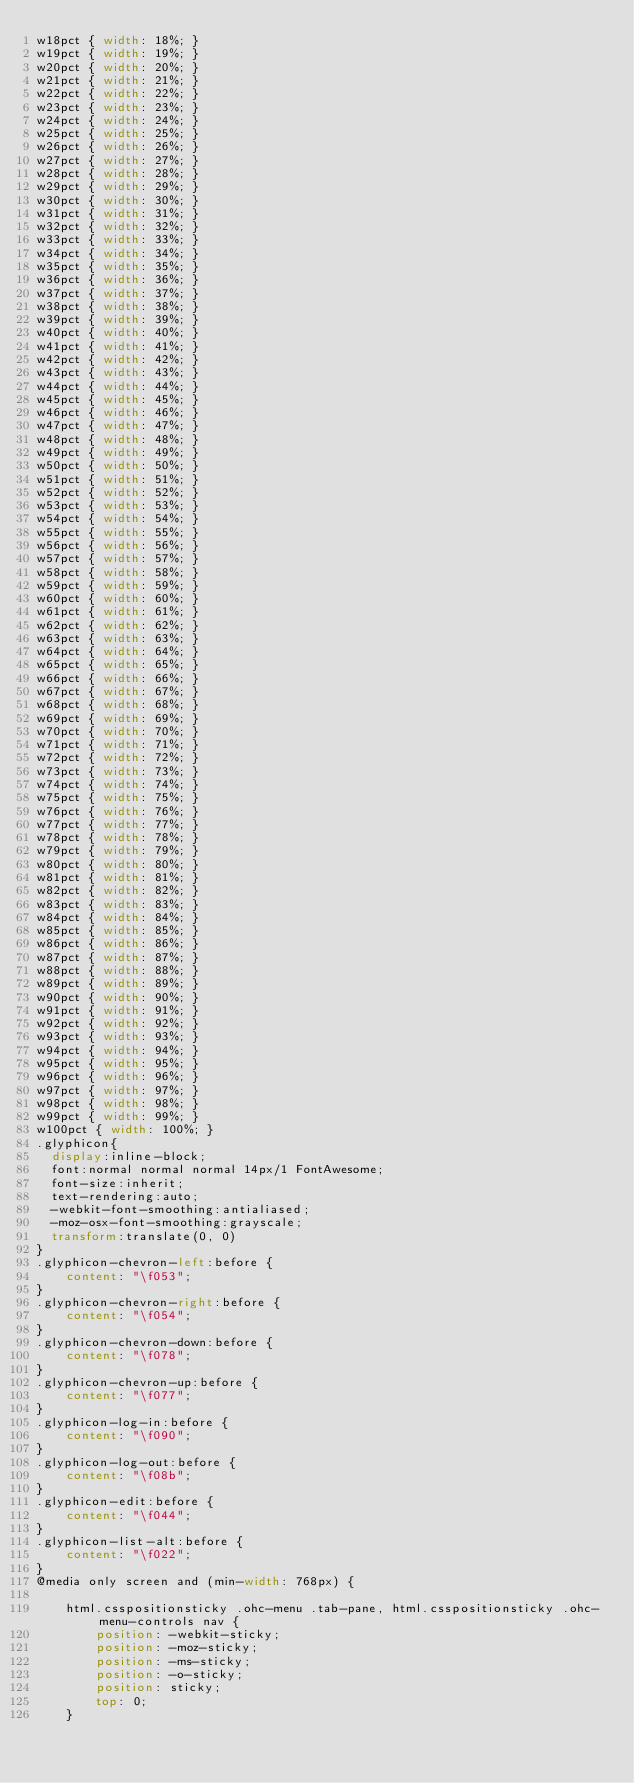Convert code to text. <code><loc_0><loc_0><loc_500><loc_500><_CSS_>w18pct { width: 18%; }
w19pct { width: 19%; }
w20pct { width: 20%; }
w21pct { width: 21%; }
w22pct { width: 22%; }
w23pct { width: 23%; }
w24pct { width: 24%; }
w25pct { width: 25%; }
w26pct { width: 26%; }
w27pct { width: 27%; }
w28pct { width: 28%; }
w29pct { width: 29%; }
w30pct { width: 30%; }
w31pct { width: 31%; }
w32pct { width: 32%; }
w33pct { width: 33%; }
w34pct { width: 34%; }
w35pct { width: 35%; }
w36pct { width: 36%; }
w37pct { width: 37%; }
w38pct { width: 38%; }
w39pct { width: 39%; }
w40pct { width: 40%; }
w41pct { width: 41%; }
w42pct { width: 42%; }
w43pct { width: 43%; }
w44pct { width: 44%; }
w45pct { width: 45%; }
w46pct { width: 46%; }
w47pct { width: 47%; }
w48pct { width: 48%; }
w49pct { width: 49%; }
w50pct { width: 50%; }
w51pct { width: 51%; }
w52pct { width: 52%; }
w53pct { width: 53%; }
w54pct { width: 54%; }
w55pct { width: 55%; }
w56pct { width: 56%; }
w57pct { width: 57%; }
w58pct { width: 58%; }
w59pct { width: 59%; }
w60pct { width: 60%; }
w61pct { width: 61%; }
w62pct { width: 62%; }
w63pct { width: 63%; }
w64pct { width: 64%; }
w65pct { width: 65%; }
w66pct { width: 66%; }
w67pct { width: 67%; }
w68pct { width: 68%; }
w69pct { width: 69%; }
w70pct { width: 70%; }
w71pct { width: 71%; }
w72pct { width: 72%; }
w73pct { width: 73%; }
w74pct { width: 74%; }
w75pct { width: 75%; }
w76pct { width: 76%; }
w77pct { width: 77%; }
w78pct { width: 78%; }
w79pct { width: 79%; }
w80pct { width: 80%; }
w81pct { width: 81%; }
w82pct { width: 82%; }
w83pct { width: 83%; }
w84pct { width: 84%; }
w85pct { width: 85%; }
w86pct { width: 86%; }
w87pct { width: 87%; }
w88pct { width: 88%; }
w89pct { width: 89%; }
w90pct { width: 90%; }
w91pct { width: 91%; }
w92pct { width: 92%; }
w93pct { width: 93%; }
w94pct { width: 94%; }
w95pct { width: 95%; }
w96pct { width: 96%; }
w97pct { width: 97%; }
w98pct { width: 98%; }
w99pct { width: 99%; }
w100pct { width: 100%; }
.glyphicon{
  display:inline-block;
  font:normal normal normal 14px/1 FontAwesome;
  font-size:inherit;
  text-rendering:auto;
  -webkit-font-smoothing:antialiased;
  -moz-osx-font-smoothing:grayscale;
  transform:translate(0, 0)
}
.glyphicon-chevron-left:before {
    content: "\f053";
}
.glyphicon-chevron-right:before {
    content: "\f054";
}
.glyphicon-chevron-down:before {
    content: "\f078";
}
.glyphicon-chevron-up:before {
    content: "\f077";
}
.glyphicon-log-in:before {
    content: "\f090";
}
.glyphicon-log-out:before {
    content: "\f08b";
}
.glyphicon-edit:before {
    content: "\f044";
}
.glyphicon-list-alt:before {
    content: "\f022";
}
@media only screen and (min-width: 768px) {
    
    html.csspositionsticky .ohc-menu .tab-pane, html.csspositionsticky .ohc-menu-controls nav {
        position: -webkit-sticky;
        position: -moz-sticky;
        position: -ms-sticky;
        position: -o-sticky;
        position: sticky;
        top: 0;
    }
    </code> 